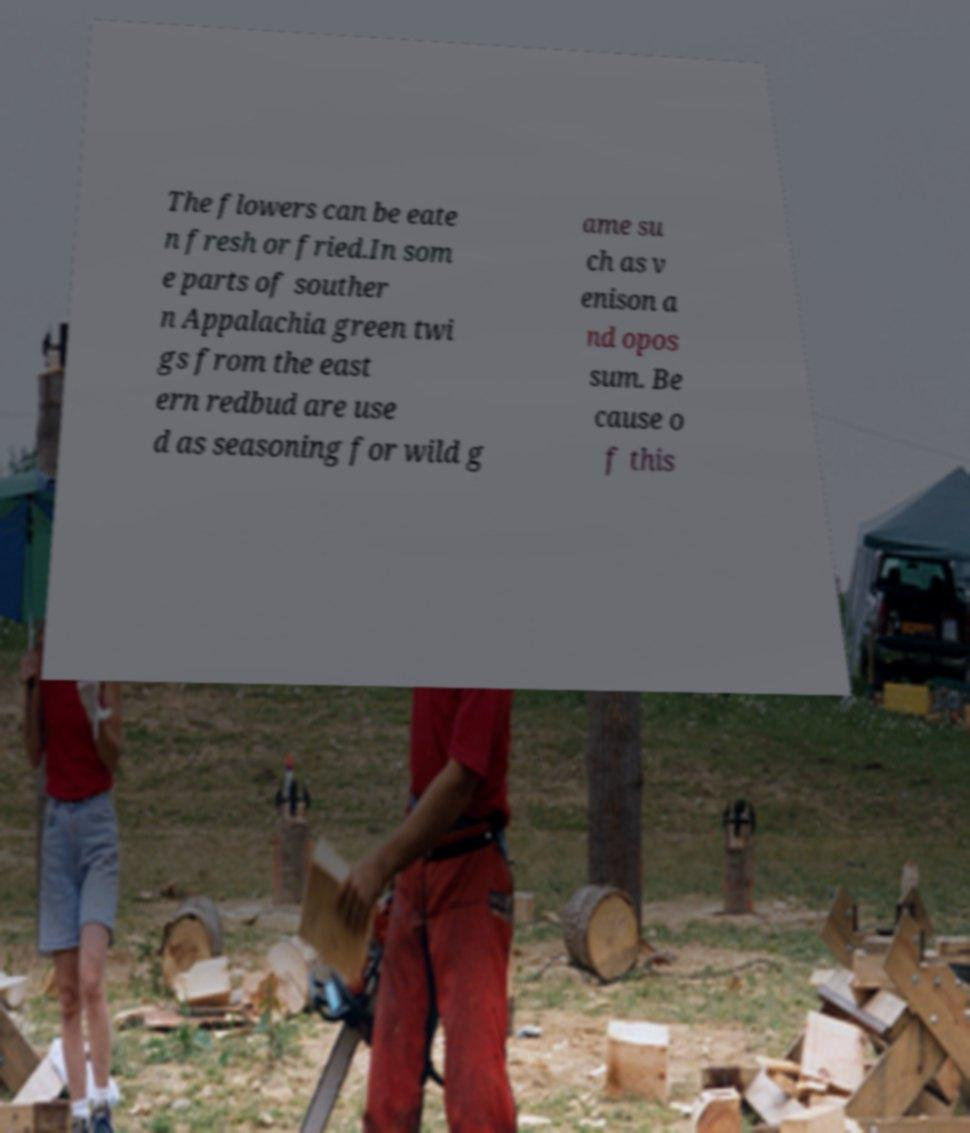Please read and relay the text visible in this image. What does it say? The flowers can be eate n fresh or fried.In som e parts of souther n Appalachia green twi gs from the east ern redbud are use d as seasoning for wild g ame su ch as v enison a nd opos sum. Be cause o f this 